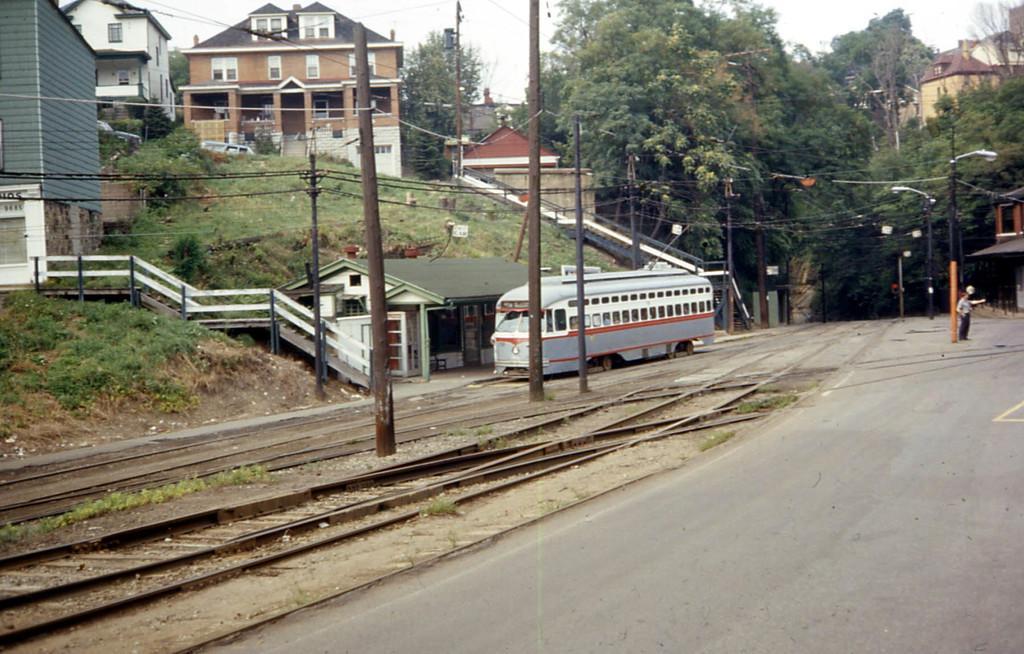How would you summarize this image in a sentence or two? In this image we can see a road and one man is standing on the road. Background buildings and trees are present. Left side of the image poles with electrical wires and electric train is present. Left bottom of the image railway tracks are there. 